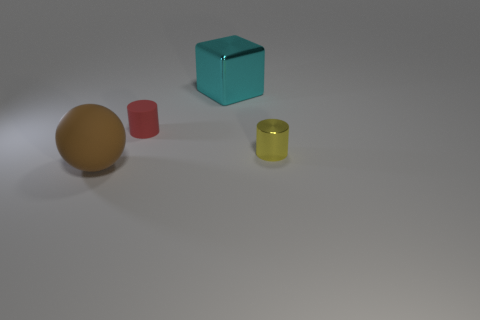Are there more big cyan things behind the big block than cyan objects in front of the yellow metal thing? No, there is only one big cyan block visible in the image, and it is situated in front of the yellow metal thing, not behind it. There are no cyan objects behind the big block. 